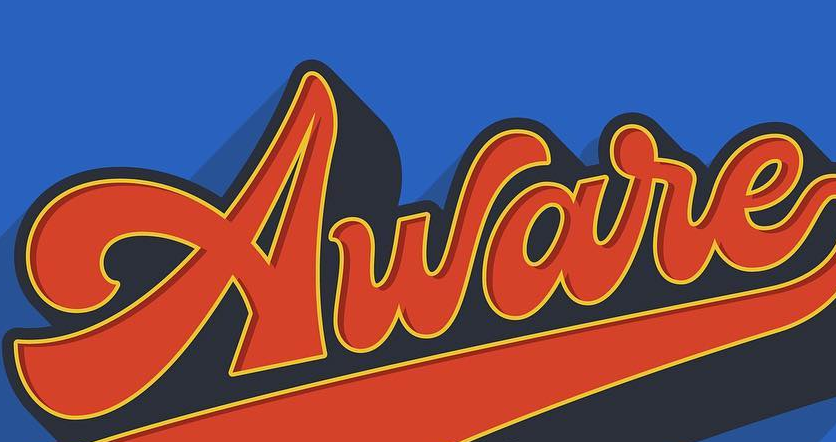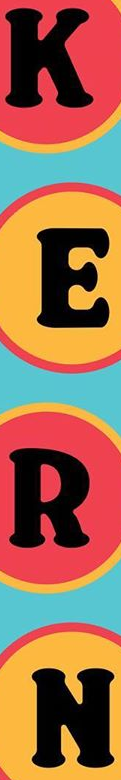Identify the words shown in these images in order, separated by a semicolon. Aware; KERT 